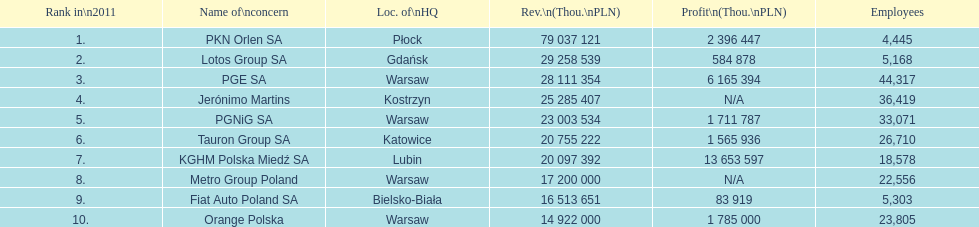What is the difference in employees for rank 1 and rank 3? 39,872 employees. 